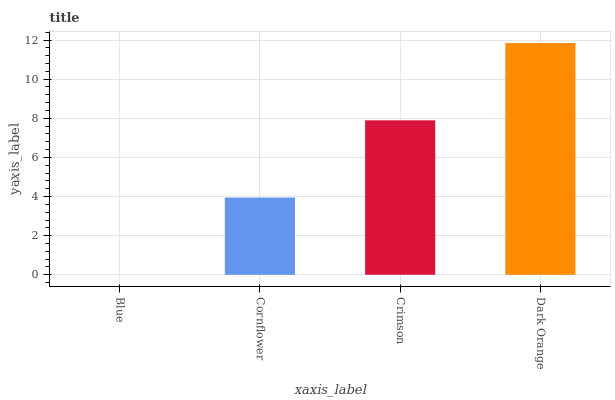Is Cornflower the minimum?
Answer yes or no. No. Is Cornflower the maximum?
Answer yes or no. No. Is Cornflower greater than Blue?
Answer yes or no. Yes. Is Blue less than Cornflower?
Answer yes or no. Yes. Is Blue greater than Cornflower?
Answer yes or no. No. Is Cornflower less than Blue?
Answer yes or no. No. Is Crimson the high median?
Answer yes or no. Yes. Is Cornflower the low median?
Answer yes or no. Yes. Is Cornflower the high median?
Answer yes or no. No. Is Dark Orange the low median?
Answer yes or no. No. 